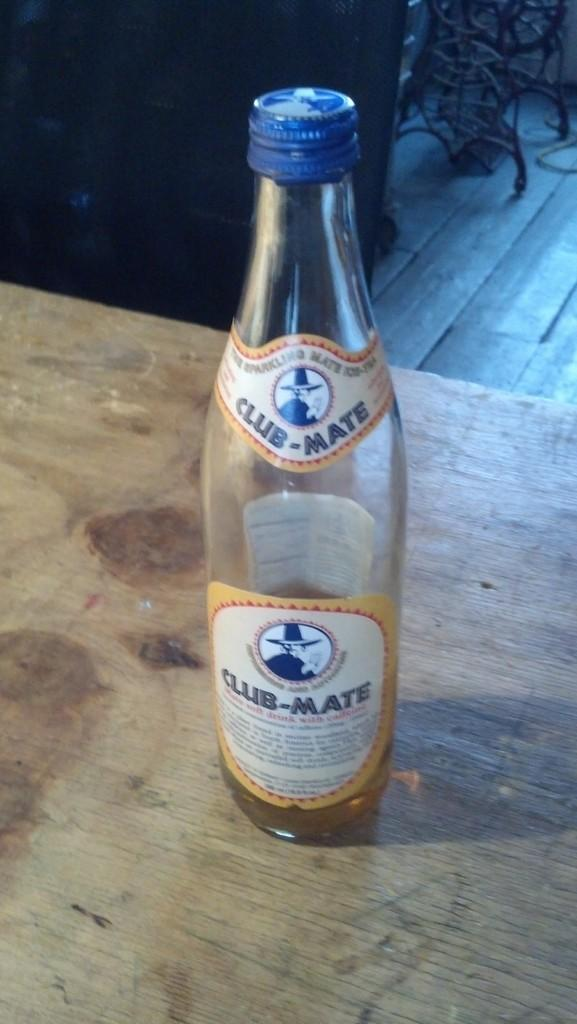<image>
Give a short and clear explanation of the subsequent image. A nearly empty bottle of Club-Mate sits on a wooden table 